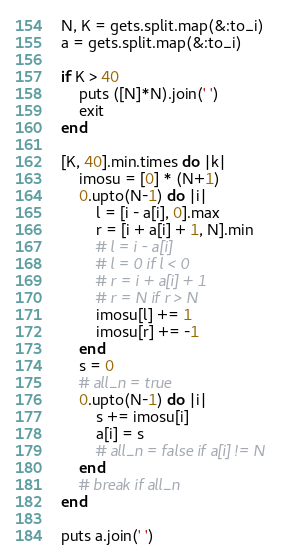Convert code to text. <code><loc_0><loc_0><loc_500><loc_500><_Ruby_>N, K = gets.split.map(&:to_i)
a = gets.split.map(&:to_i)

if K > 40
    puts ([N]*N).join(' ')
    exit
end

[K, 40].min.times do |k|
    imosu = [0] * (N+1)
    0.upto(N-1) do |i|
        l = [i - a[i], 0].max
        r = [i + a[i] + 1, N].min
        # l = i - a[i]
        # l = 0 if l < 0
        # r = i + a[i] + 1
        # r = N if r > N
        imosu[l] += 1
        imosu[r] += -1
    end
    s = 0
    # all_n = true
    0.upto(N-1) do |i|
        s += imosu[i]
        a[i] = s
        # all_n = false if a[i] != N
    end
    # break if all_n
end

puts a.join(' ')</code> 